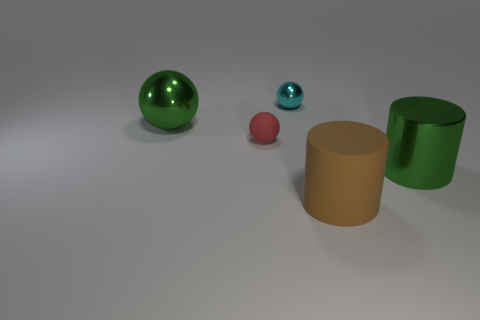Subtract all small balls. How many balls are left? 1 Add 2 large metallic things. How many objects exist? 7 Subtract 1 spheres. How many spheres are left? 2 Subtract all cylinders. How many objects are left? 3 Add 5 brown matte things. How many brown matte things exist? 6 Subtract 0 gray balls. How many objects are left? 5 Subtract all purple balls. Subtract all red cylinders. How many balls are left? 3 Subtract all small gray metallic spheres. Subtract all brown cylinders. How many objects are left? 4 Add 4 big rubber cylinders. How many big rubber cylinders are left? 5 